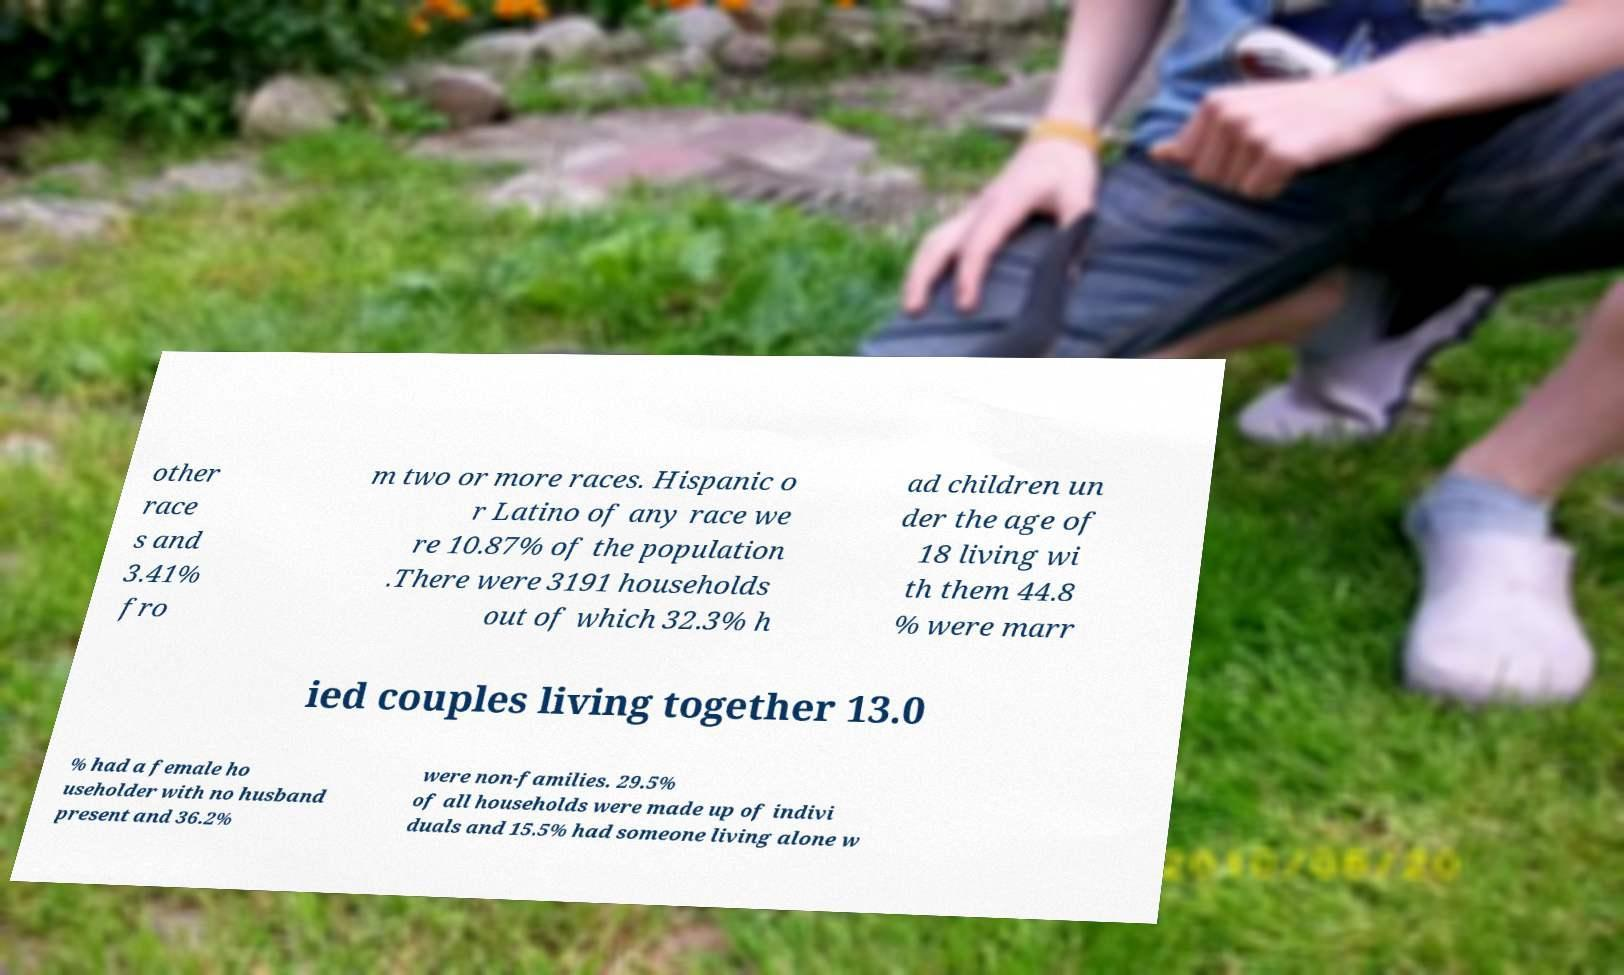Could you assist in decoding the text presented in this image and type it out clearly? other race s and 3.41% fro m two or more races. Hispanic o r Latino of any race we re 10.87% of the population .There were 3191 households out of which 32.3% h ad children un der the age of 18 living wi th them 44.8 % were marr ied couples living together 13.0 % had a female ho useholder with no husband present and 36.2% were non-families. 29.5% of all households were made up of indivi duals and 15.5% had someone living alone w 